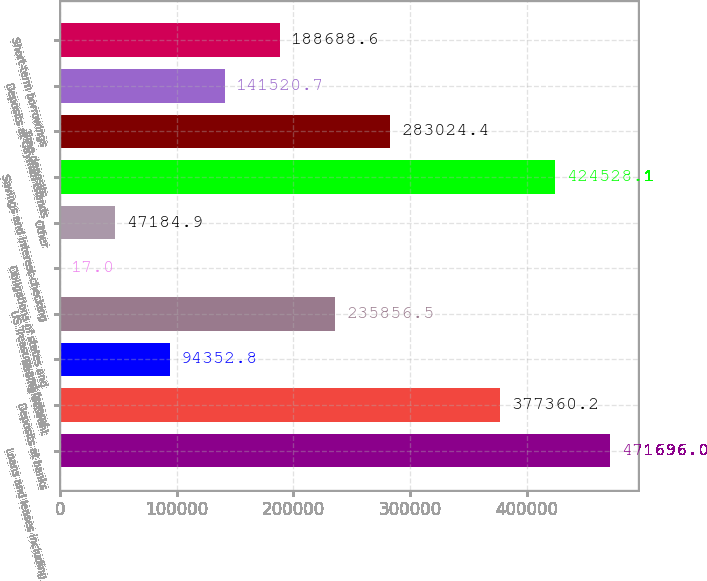Convert chart. <chart><loc_0><loc_0><loc_500><loc_500><bar_chart><fcel>Loans and leases including<fcel>Deposits at banks<fcel>Trading account<fcel>US Treasury and federal<fcel>Obligations of states and<fcel>Other<fcel>Savings and interest-checking<fcel>Time deposits<fcel>Deposits at Cayman Islands<fcel>Short-term borrowings<nl><fcel>471696<fcel>377360<fcel>94352.8<fcel>235856<fcel>17<fcel>47184.9<fcel>424528<fcel>283024<fcel>141521<fcel>188689<nl></chart> 